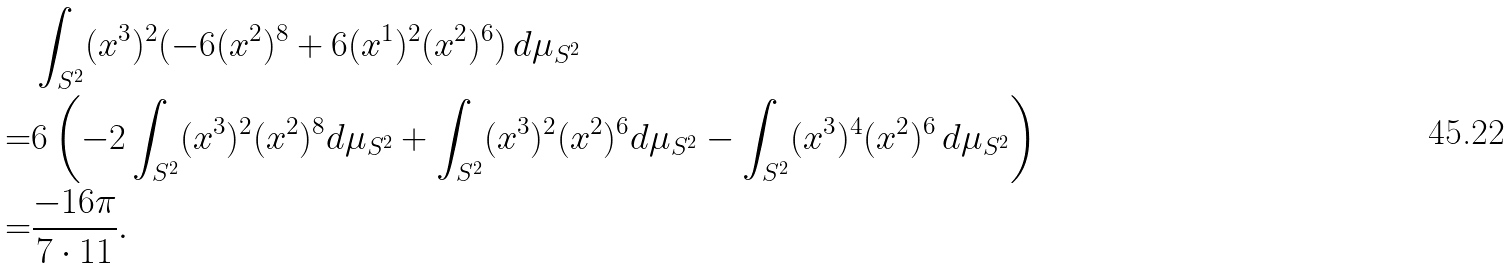Convert formula to latex. <formula><loc_0><loc_0><loc_500><loc_500>& \int _ { S ^ { 2 } } ( x ^ { 3 } ) ^ { 2 } ( - 6 ( x ^ { 2 } ) ^ { 8 } + 6 ( x ^ { 1 } ) ^ { 2 } ( x ^ { 2 } ) ^ { 6 } ) \, d \mu _ { S ^ { 2 } } \\ = & 6 \left ( - 2 \int _ { S ^ { 2 } } ( x ^ { 3 } ) ^ { 2 } ( x ^ { 2 } ) ^ { 8 } d \mu _ { S ^ { 2 } } + \int _ { S ^ { 2 } } ( x ^ { 3 } ) ^ { 2 } ( x ^ { 2 } ) ^ { 6 } d \mu _ { S ^ { 2 } } - \int _ { S ^ { 2 } } ( x ^ { 3 } ) ^ { 4 } ( x ^ { 2 } ) ^ { 6 } \, d \mu _ { S ^ { 2 } } \right ) \\ = & \frac { - 1 6 \pi } { 7 \cdot 1 1 } .</formula> 